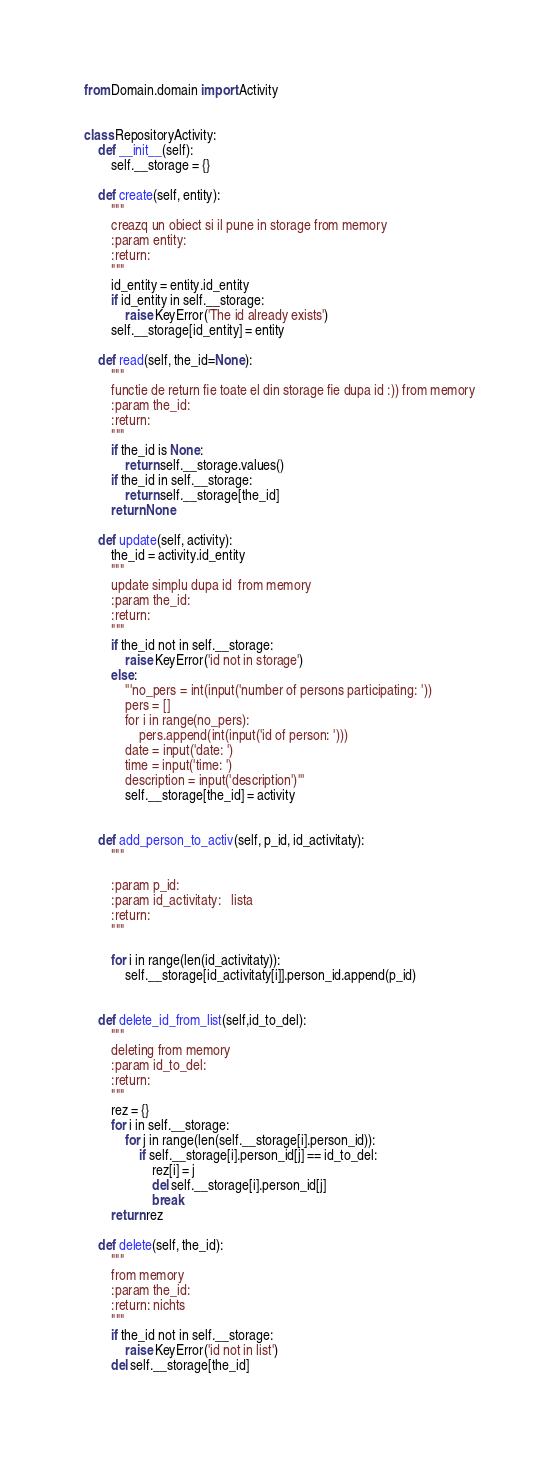<code> <loc_0><loc_0><loc_500><loc_500><_Python_>from Domain.domain import Activity


class RepositoryActivity:
    def __init__(self):
        self.__storage = {}

    def create(self, entity):
        """
        creazq un obiect si il pune in storage from memory
        :param entity:
        :return:
        """
        id_entity = entity.id_entity
        if id_entity in self.__storage:
            raise KeyError('The id already exists')
        self.__storage[id_entity] = entity

    def read(self, the_id=None):
        """
        functie de return fie toate el din storage fie dupa id :)) from memory
        :param the_id:
        :return:
        """
        if the_id is None:
            return self.__storage.values()
        if the_id in self.__storage:
            return self.__storage[the_id]
        return None

    def update(self, activity):
        the_id = activity.id_entity
        """
        update simplu dupa id  from memory
        :param the_id:
        :return:
        """
        if the_id not in self.__storage:
            raise KeyError('id not in storage')
        else:
            '''no_pers = int(input('number of persons participating: '))
            pers = []
            for i in range(no_pers):
                pers.append(int(input('id of person: ')))
            date = input('date: ')
            time = input('time: ')
            description = input('description')'''
            self.__storage[the_id] = activity


    def add_person_to_activ(self, p_id, id_activitaty):
        """

        :param p_id:
        :param id_activitaty:   lista
        :return:
        """

        for i in range(len(id_activitaty)):
            self.__storage[id_activitaty[i]].person_id.append(p_id)


    def delete_id_from_list(self,id_to_del):
        """
        deleting from memory
        :param id_to_del:
        :return:
        """
        rez = {}
        for i in self.__storage:
            for j in range(len(self.__storage[i].person_id)):
                if self.__storage[i].person_id[j] == id_to_del:
                    rez[i] = j
                    del self.__storage[i].person_id[j]
                    break
        return rez

    def delete(self, the_id):
        """
        from memory
        :param the_id:
        :return: nichts
        """
        if the_id not in self.__storage:
            raise KeyError('id not in list')
        del self.__storage[the_id]
</code> 